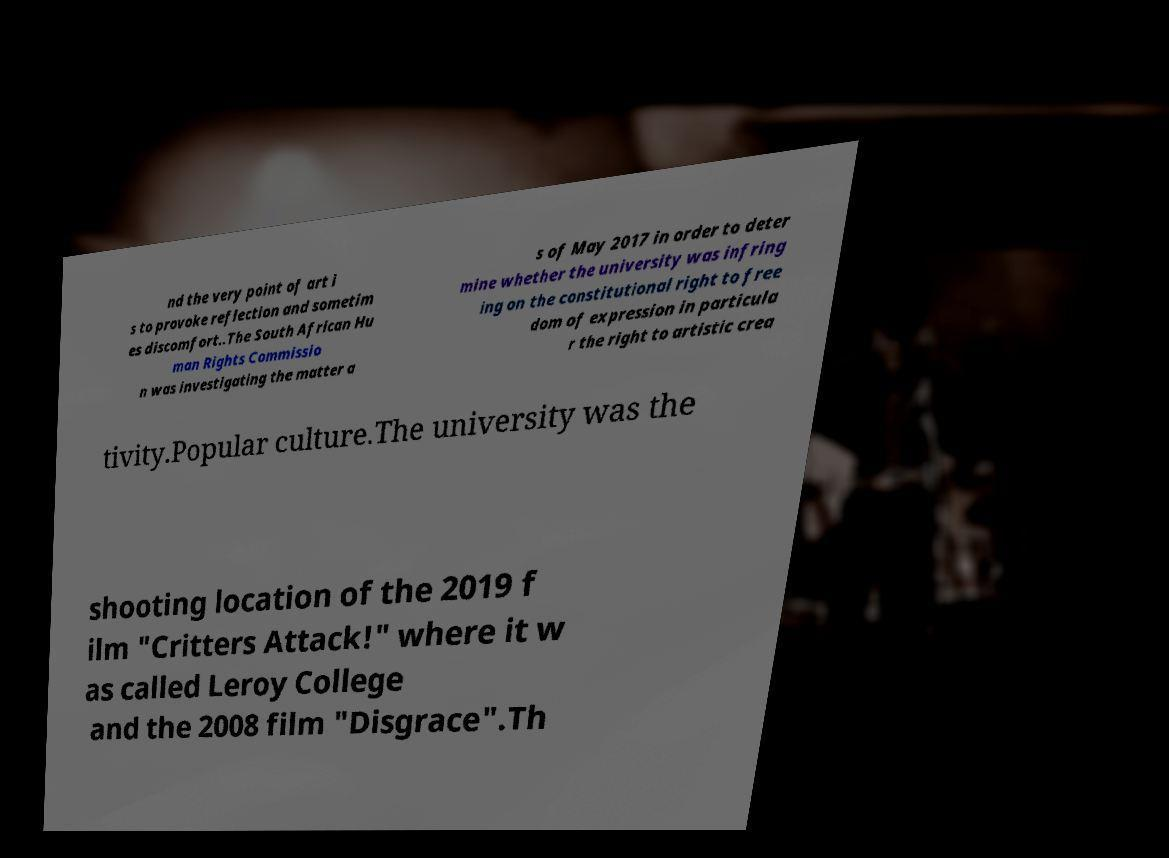For documentation purposes, I need the text within this image transcribed. Could you provide that? nd the very point of art i s to provoke reflection and sometim es discomfort..The South African Hu man Rights Commissio n was investigating the matter a s of May 2017 in order to deter mine whether the university was infring ing on the constitutional right to free dom of expression in particula r the right to artistic crea tivity.Popular culture.The university was the shooting location of the 2019 f ilm "Critters Attack!" where it w as called Leroy College and the 2008 film "Disgrace".Th 